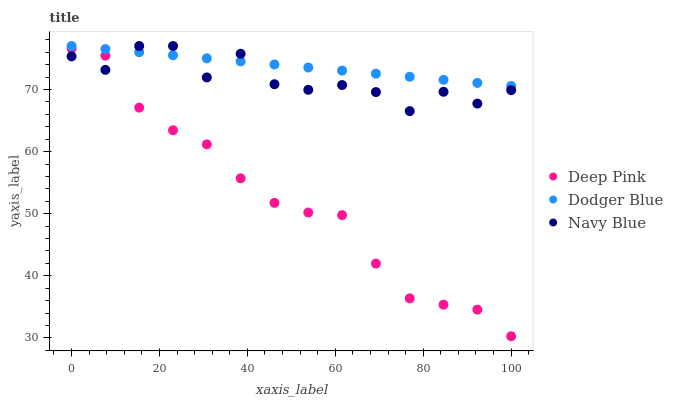Does Deep Pink have the minimum area under the curve?
Answer yes or no. Yes. Does Dodger Blue have the maximum area under the curve?
Answer yes or no. Yes. Does Dodger Blue have the minimum area under the curve?
Answer yes or no. No. Does Deep Pink have the maximum area under the curve?
Answer yes or no. No. Is Dodger Blue the smoothest?
Answer yes or no. Yes. Is Navy Blue the roughest?
Answer yes or no. Yes. Is Deep Pink the smoothest?
Answer yes or no. No. Is Deep Pink the roughest?
Answer yes or no. No. Does Deep Pink have the lowest value?
Answer yes or no. Yes. Does Dodger Blue have the lowest value?
Answer yes or no. No. Does Dodger Blue have the highest value?
Answer yes or no. Yes. Does Deep Pink have the highest value?
Answer yes or no. No. Is Deep Pink less than Dodger Blue?
Answer yes or no. Yes. Is Dodger Blue greater than Deep Pink?
Answer yes or no. Yes. Does Navy Blue intersect Dodger Blue?
Answer yes or no. Yes. Is Navy Blue less than Dodger Blue?
Answer yes or no. No. Is Navy Blue greater than Dodger Blue?
Answer yes or no. No. Does Deep Pink intersect Dodger Blue?
Answer yes or no. No. 